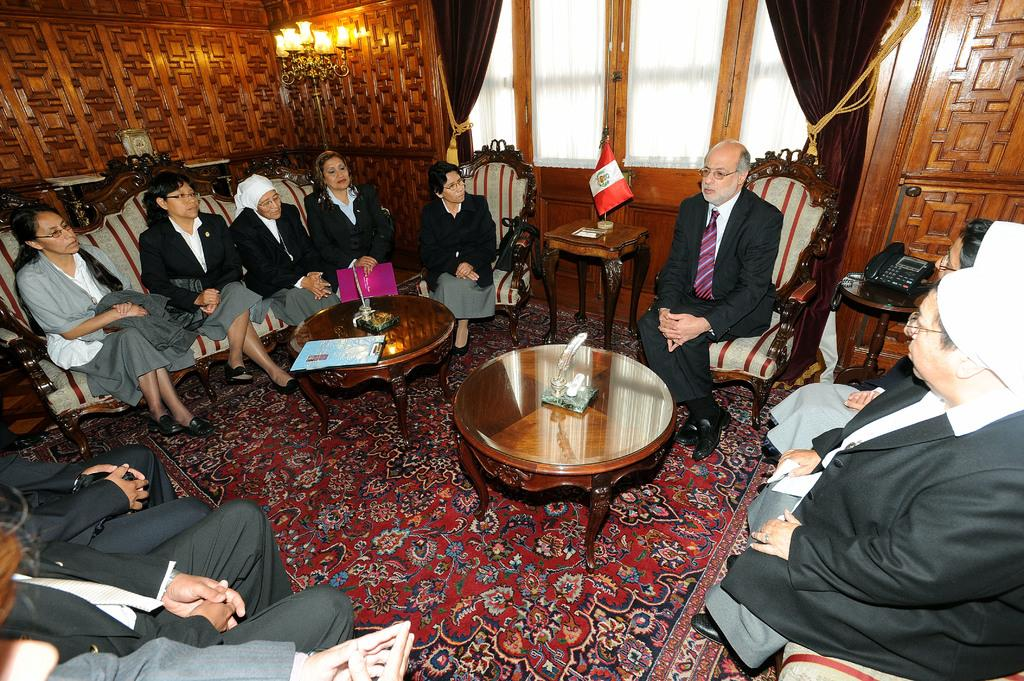Who is present in the image? There are people in the image. What are the people doing in the image? The people are sitting on a sofa and chairs. What type of wax is being used to protest in the image? There is no wax or protest present in the image. What flavor of soda is being consumed by the people in the image? There is no soda present in the image. 